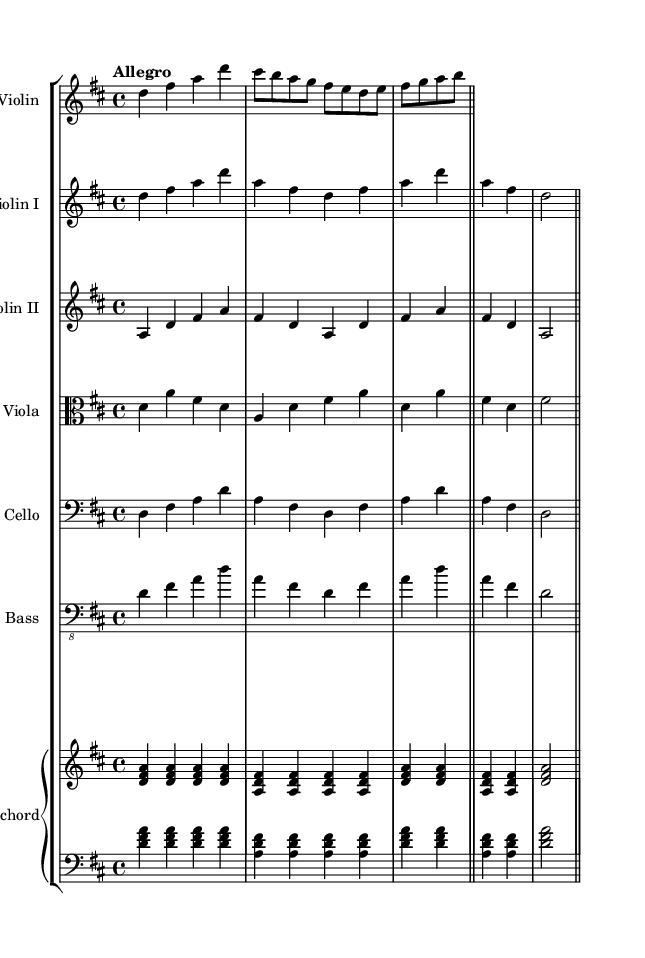What is the key signature of this music? The key signature is D major, which has two sharps (F# and C#). This can be identified at the beginning of the score where the key signature is notated.
Answer: D major What is the time signature of this piece? The time signature is 4/4, indicated at the beginning of the score where the time signature is displayed. This signifies that there are four beats in a measure and a quarter note receives one beat.
Answer: 4/4 What is the tempo marking of the piece? The tempo marking is "Allegro," which is noted at the beginning of the score. Allegro generally means a fast tempo, typically between 120 and 168 beats per minute.
Answer: Allegro How many instruments are featured in this orchestral piece? The orchestral piece features six distinct instruments, which are listed in the corresponding staves at the start of the score: solo violin, violin I, violin II, viola, cello, double bass, and harpsichord. Each is represented separately on its own staff.
Answer: Six Which instrument plays the lowest in this arrangement? The instrument that plays the lowest is the double bass, which is notated in the bass clef. In orchestral music, the double bass typically provides the lowest pitches, supporting the harmonic structure.
Answer: Double bass What type of musical texture is primarily present in this piece? The musical texture is primarily polyphonic, as evident from multiple independent melodic lines played simultaneously by different instruments, a common characteristic of Baroque music where counterpoint is prevalent.
Answer: Polyphonic Which instrument has the solo melody in this composition? The solo violin has the solo melody, as indicated by its part being notated separately at the beginning and featuring distinct melodic lines throughout the piece.
Answer: Solo violin 